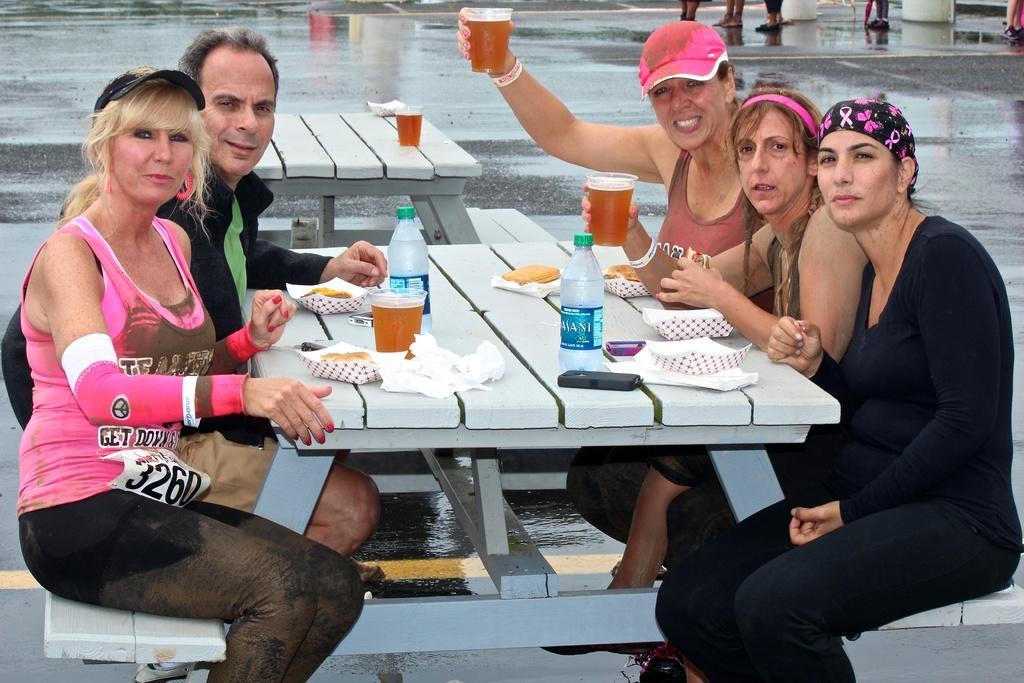Could you give a brief overview of what you see in this image? This picture describe about the road side view of the four woman and a one man who is sitting on the white bench and eating some snacks. On the white table we can see some food with tissue papers, two water bottles and glass of wine. Behind we can see the wet road and some foods of the people who is standing behind them. 